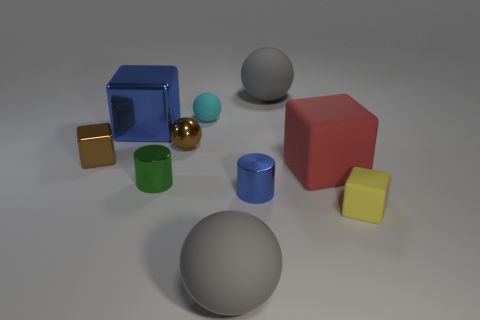Subtract all tiny brown metallic balls. How many balls are left? 3 Subtract all spheres. How many objects are left? 6 Subtract all cyan spheres. How many spheres are left? 3 Subtract 0 red balls. How many objects are left? 10 Subtract 2 spheres. How many spheres are left? 2 Subtract all yellow balls. Subtract all brown cubes. How many balls are left? 4 Subtract all brown cylinders. How many brown balls are left? 1 Subtract all metallic objects. Subtract all cylinders. How many objects are left? 3 Add 6 gray balls. How many gray balls are left? 8 Add 2 gray balls. How many gray balls exist? 4 